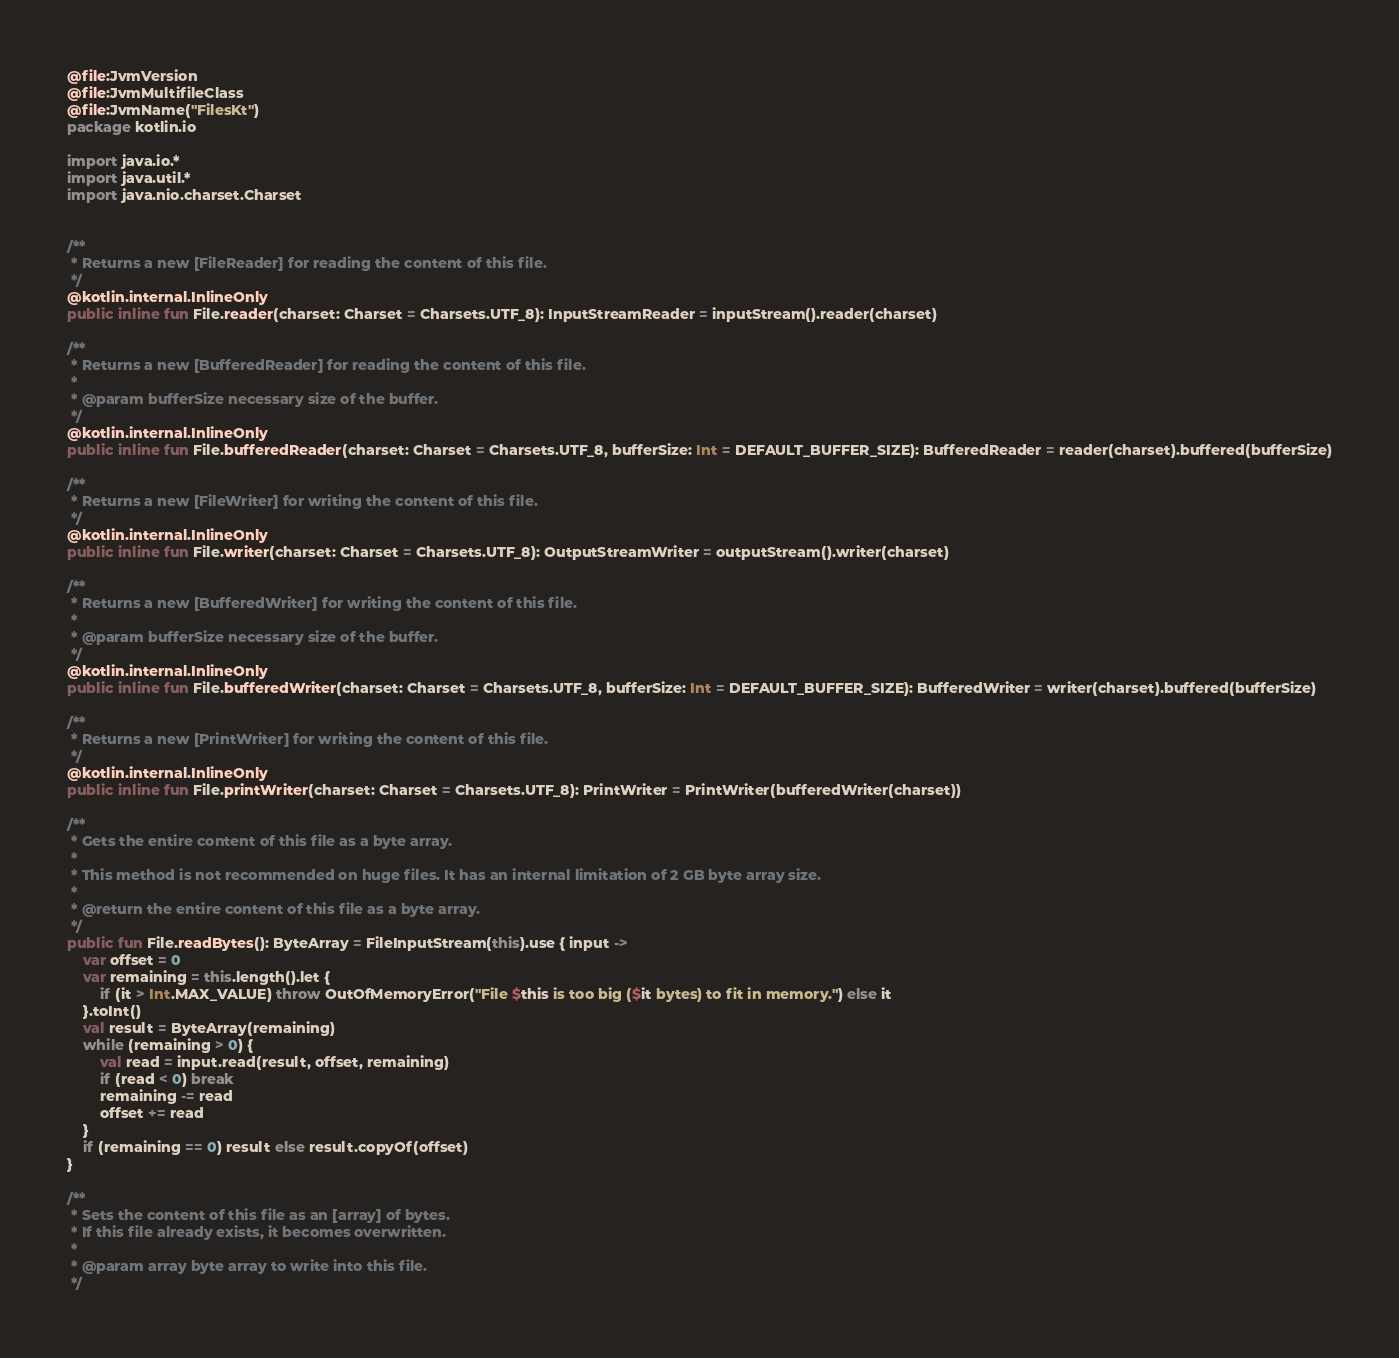Convert code to text. <code><loc_0><loc_0><loc_500><loc_500><_Kotlin_>@file:JvmVersion
@file:JvmMultifileClass
@file:JvmName("FilesKt")
package kotlin.io

import java.io.*
import java.util.*
import java.nio.charset.Charset


/**
 * Returns a new [FileReader] for reading the content of this file.
 */
@kotlin.internal.InlineOnly
public inline fun File.reader(charset: Charset = Charsets.UTF_8): InputStreamReader = inputStream().reader(charset)

/**
 * Returns a new [BufferedReader] for reading the content of this file.
 *
 * @param bufferSize necessary size of the buffer.
 */
@kotlin.internal.InlineOnly
public inline fun File.bufferedReader(charset: Charset = Charsets.UTF_8, bufferSize: Int = DEFAULT_BUFFER_SIZE): BufferedReader = reader(charset).buffered(bufferSize)

/**
 * Returns a new [FileWriter] for writing the content of this file.
 */
@kotlin.internal.InlineOnly
public inline fun File.writer(charset: Charset = Charsets.UTF_8): OutputStreamWriter = outputStream().writer(charset)

/**
 * Returns a new [BufferedWriter] for writing the content of this file.
 *
 * @param bufferSize necessary size of the buffer.
 */
@kotlin.internal.InlineOnly
public inline fun File.bufferedWriter(charset: Charset = Charsets.UTF_8, bufferSize: Int = DEFAULT_BUFFER_SIZE): BufferedWriter = writer(charset).buffered(bufferSize)

/**
 * Returns a new [PrintWriter] for writing the content of this file.
 */
@kotlin.internal.InlineOnly
public inline fun File.printWriter(charset: Charset = Charsets.UTF_8): PrintWriter = PrintWriter(bufferedWriter(charset))

/**
 * Gets the entire content of this file as a byte array.
 *
 * This method is not recommended on huge files. It has an internal limitation of 2 GB byte array size.
 *
 * @return the entire content of this file as a byte array.
 */
public fun File.readBytes(): ByteArray = FileInputStream(this).use { input ->
    var offset = 0
    var remaining = this.length().let {
        if (it > Int.MAX_VALUE) throw OutOfMemoryError("File $this is too big ($it bytes) to fit in memory.") else it
    }.toInt()
    val result = ByteArray(remaining)
    while (remaining > 0) {
        val read = input.read(result, offset, remaining)
        if (read < 0) break
        remaining -= read
        offset += read
    }
    if (remaining == 0) result else result.copyOf(offset)
}

/**
 * Sets the content of this file as an [array] of bytes.
 * If this file already exists, it becomes overwritten.
 *
 * @param array byte array to write into this file.
 */</code> 